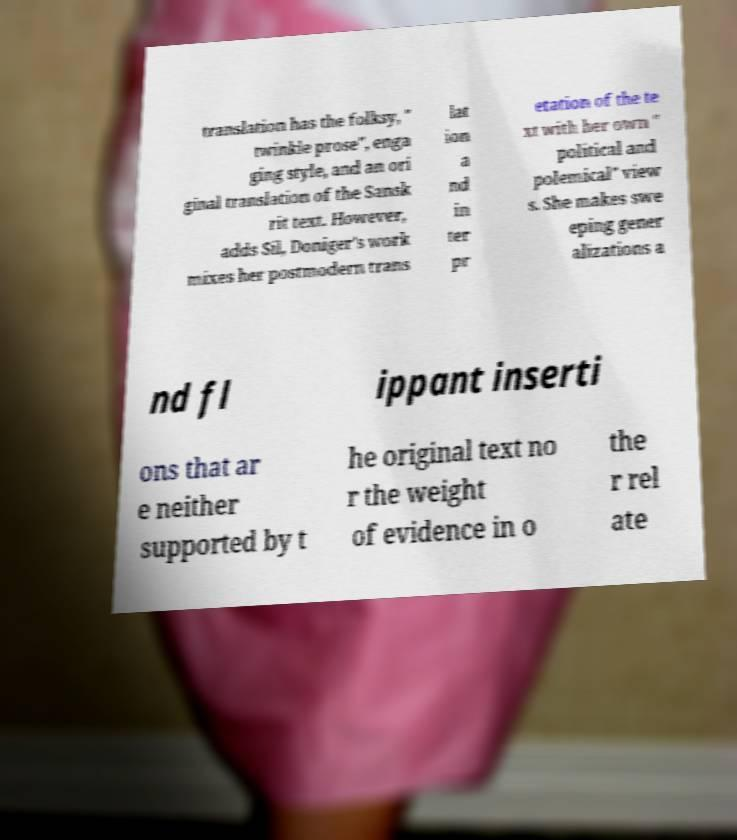Please read and relay the text visible in this image. What does it say? translation has the folksy, " twinkle prose", enga ging style, and an ori ginal translation of the Sansk rit text. However, adds Sil, Doniger's work mixes her postmodern trans lat ion a nd in ter pr etation of the te xt with her own " political and polemical" view s. She makes swe eping gener alizations a nd fl ippant inserti ons that ar e neither supported by t he original text no r the weight of evidence in o the r rel ate 